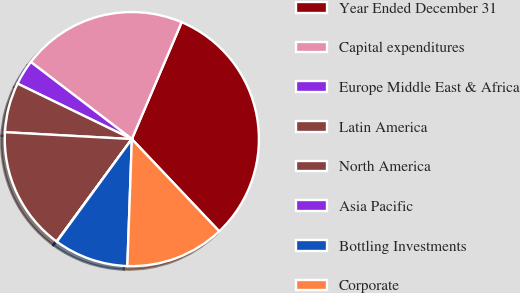Convert chart to OTSL. <chart><loc_0><loc_0><loc_500><loc_500><pie_chart><fcel>Year Ended December 31<fcel>Capital expenditures<fcel>Europe Middle East & Africa<fcel>Latin America<fcel>North America<fcel>Asia Pacific<fcel>Bottling Investments<fcel>Corporate<nl><fcel>31.52%<fcel>21.04%<fcel>3.18%<fcel>6.33%<fcel>15.78%<fcel>0.04%<fcel>9.48%<fcel>12.63%<nl></chart> 